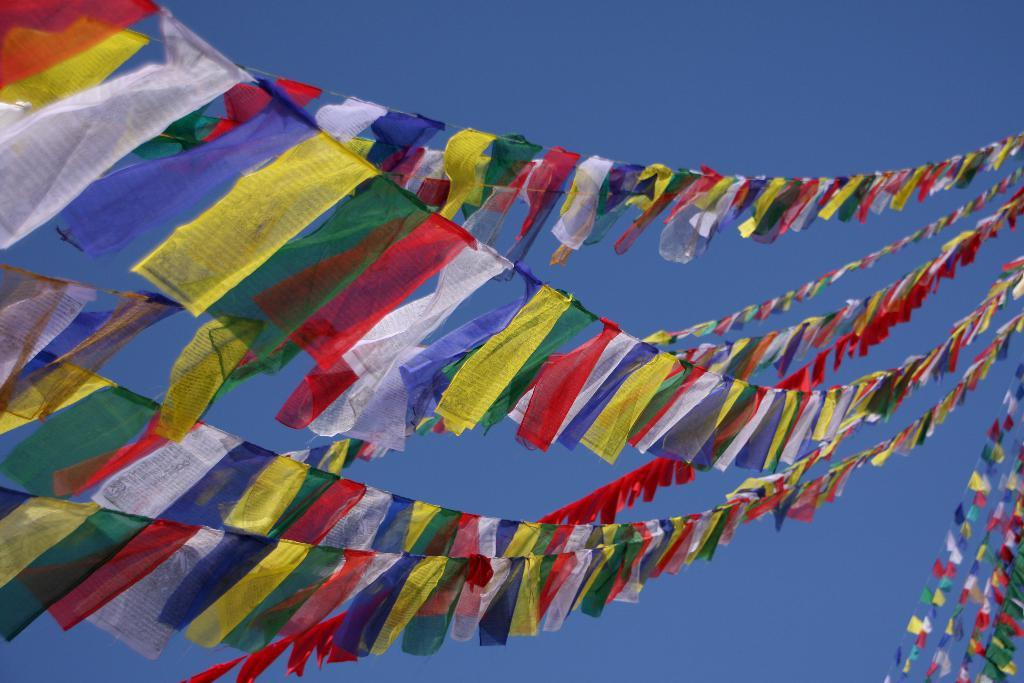What type of decorative item can be seen in the image? There are decoration ribbons in the image. How are the ribbons attached or connected? The ribbons are tied to a thread. What can be seen in the background of the image? The background of the image includes the sky. What type of plant can be seen growing on the coast in the image? There is no plant or coast visible in the image; it only features decoration ribbons tied to a thread with the sky in the background. 